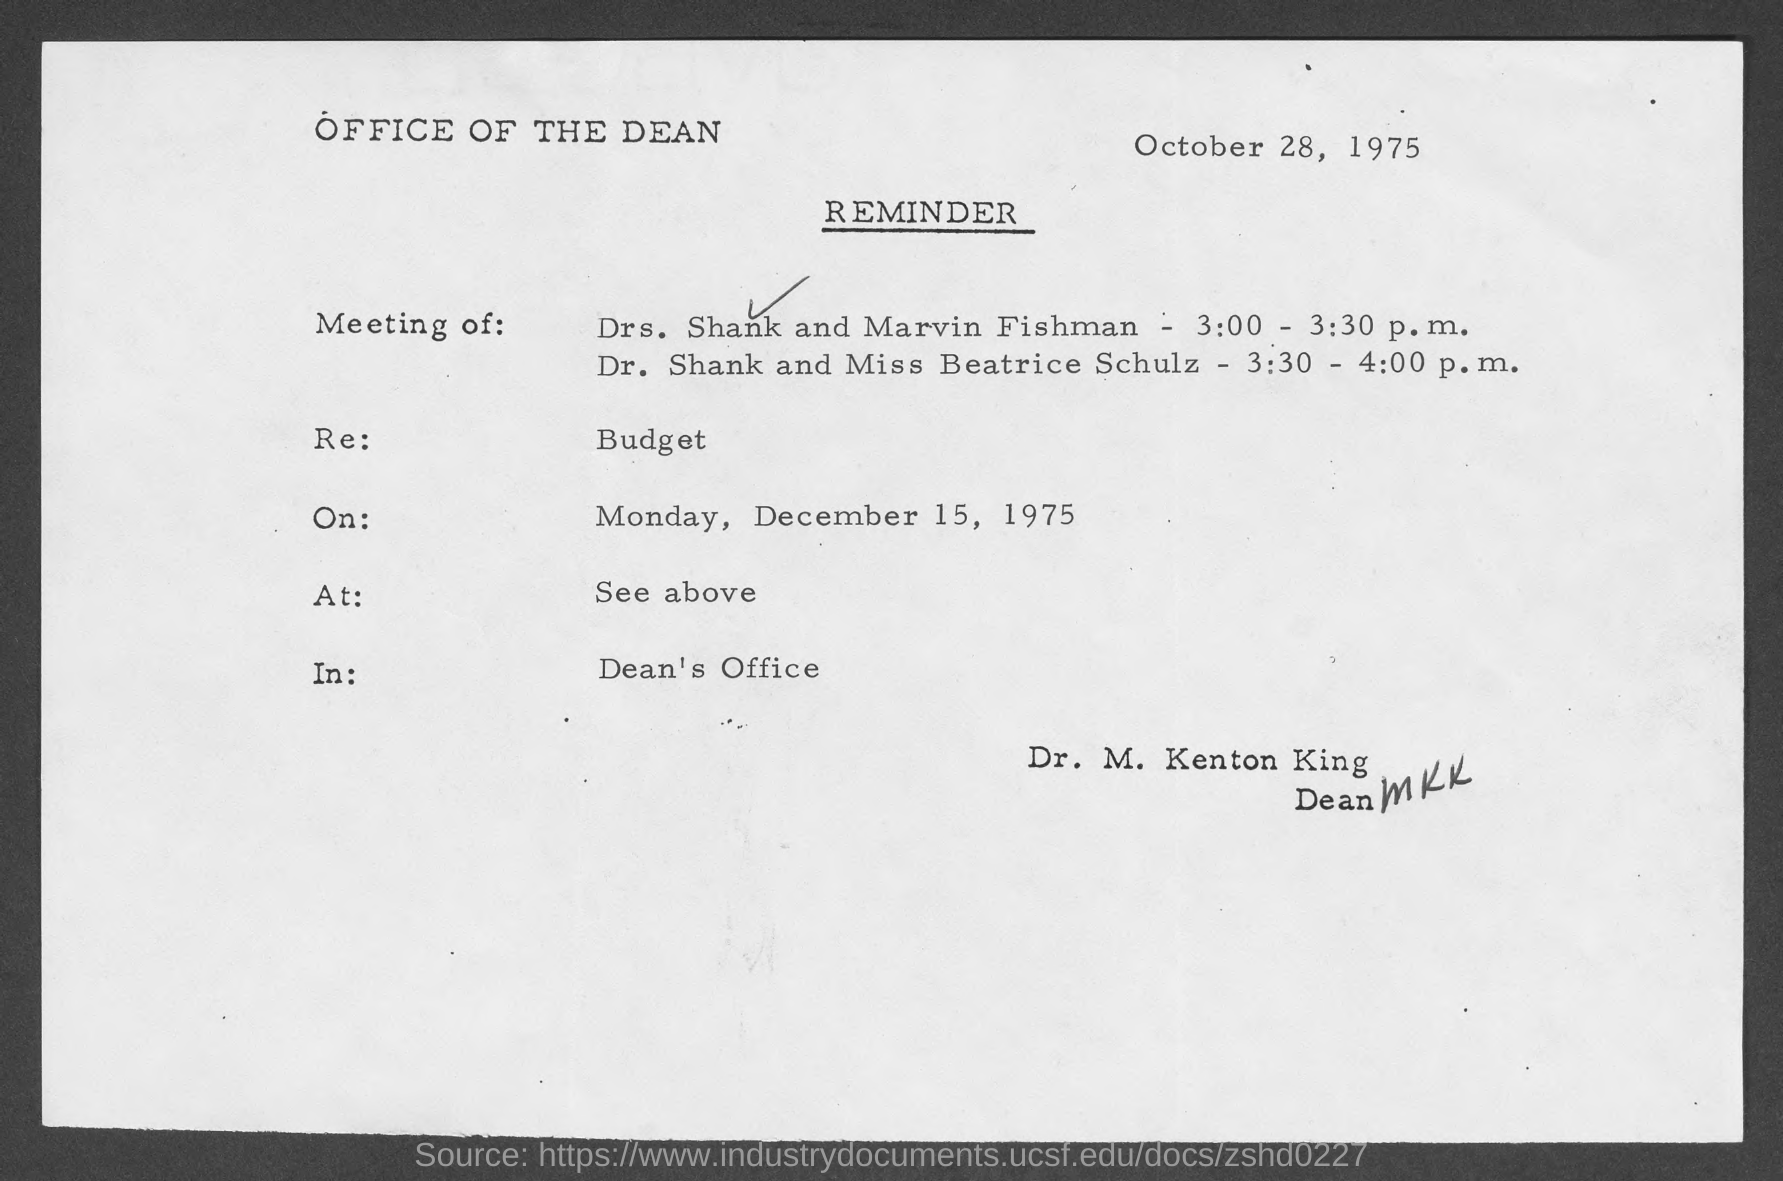Give some essential details in this illustration. The reminder is the revenue of the budget. The meeting is scheduled for December 15, 1975. The reminder is dated October 28, 1975. The venue for the meeting is the Dean's office. The meeting is scheduled for Monday. 